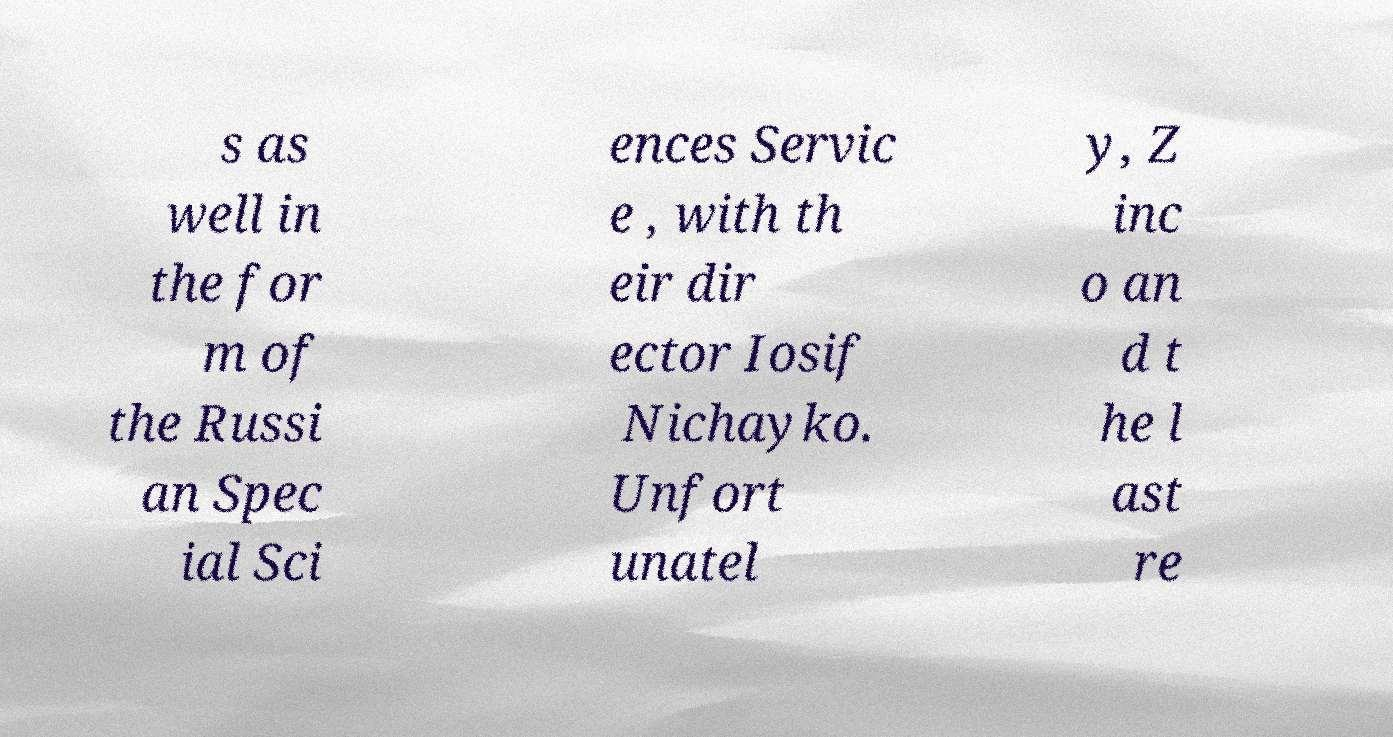What messages or text are displayed in this image? I need them in a readable, typed format. s as well in the for m of the Russi an Spec ial Sci ences Servic e , with th eir dir ector Iosif Nichayko. Unfort unatel y, Z inc o an d t he l ast re 